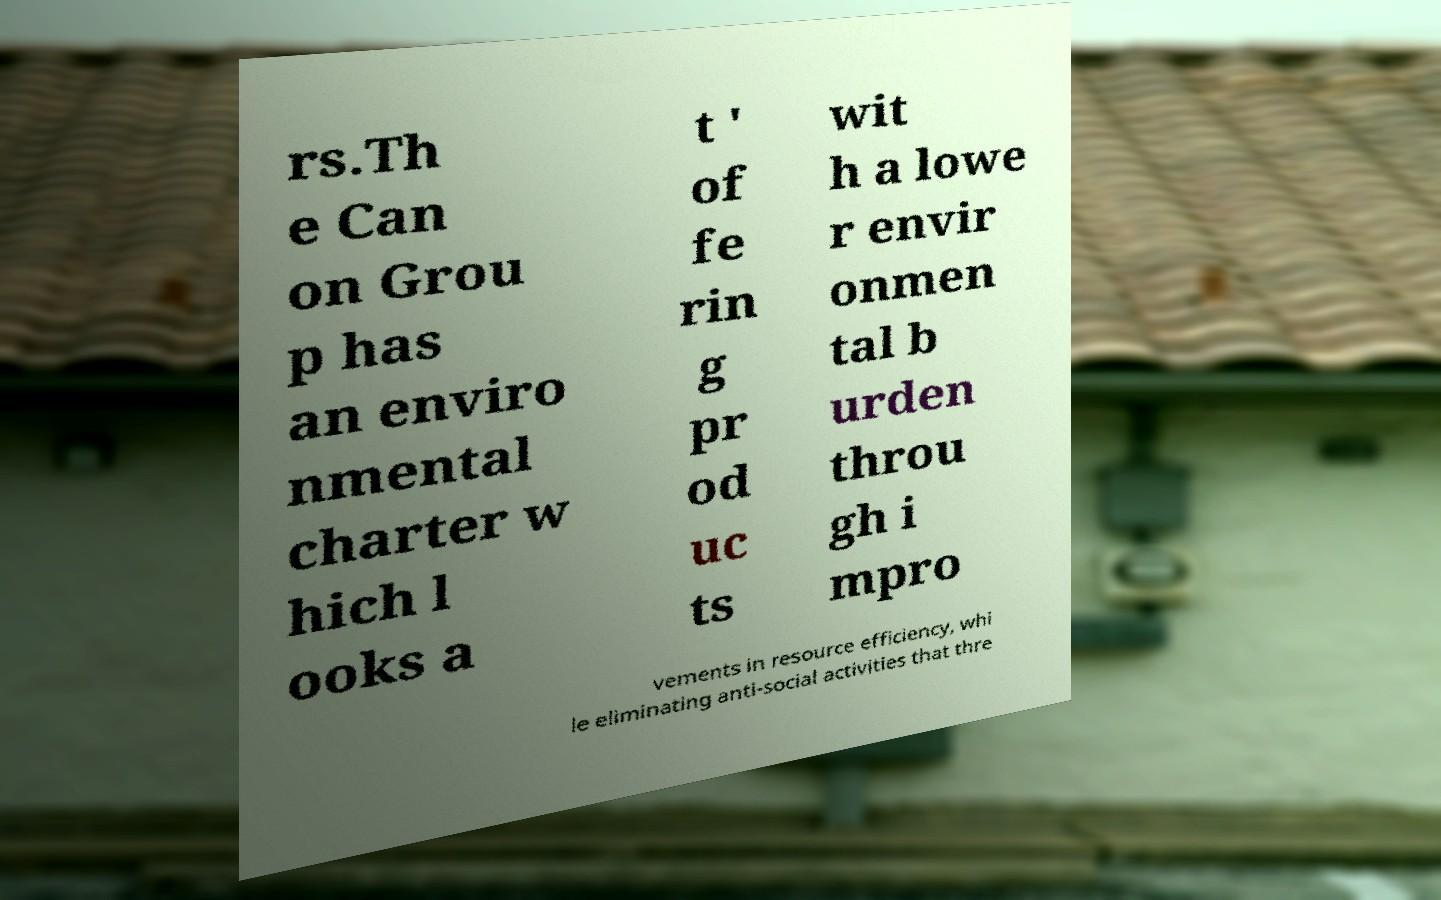There's text embedded in this image that I need extracted. Can you transcribe it verbatim? rs.Th e Can on Grou p has an enviro nmental charter w hich l ooks a t ' of fe rin g pr od uc ts wit h a lowe r envir onmen tal b urden throu gh i mpro vements in resource efficiency, whi le eliminating anti-social activities that thre 